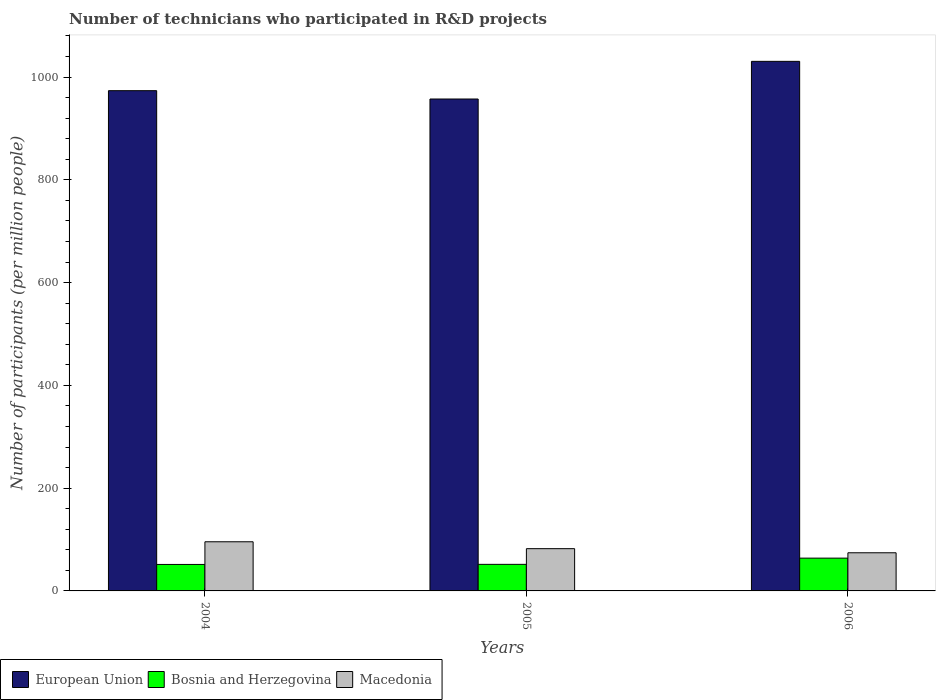How many different coloured bars are there?
Make the answer very short. 3. Are the number of bars on each tick of the X-axis equal?
Offer a very short reply. Yes. How many bars are there on the 1st tick from the right?
Ensure brevity in your answer.  3. What is the label of the 3rd group of bars from the left?
Your response must be concise. 2006. In how many cases, is the number of bars for a given year not equal to the number of legend labels?
Your answer should be compact. 0. What is the number of technicians who participated in R&D projects in European Union in 2004?
Give a very brief answer. 973.54. Across all years, what is the maximum number of technicians who participated in R&D projects in Bosnia and Herzegovina?
Make the answer very short. 63.8. Across all years, what is the minimum number of technicians who participated in R&D projects in Macedonia?
Offer a terse response. 74.24. What is the total number of technicians who participated in R&D projects in European Union in the graph?
Make the answer very short. 2961.45. What is the difference between the number of technicians who participated in R&D projects in European Union in 2004 and that in 2005?
Offer a very short reply. 16.22. What is the difference between the number of technicians who participated in R&D projects in Bosnia and Herzegovina in 2006 and the number of technicians who participated in R&D projects in European Union in 2004?
Offer a very short reply. -909.74. What is the average number of technicians who participated in R&D projects in European Union per year?
Ensure brevity in your answer.  987.15. In the year 2004, what is the difference between the number of technicians who participated in R&D projects in Bosnia and Herzegovina and number of technicians who participated in R&D projects in Macedonia?
Your answer should be very brief. -44.15. What is the ratio of the number of technicians who participated in R&D projects in European Union in 2004 to that in 2005?
Ensure brevity in your answer.  1.02. Is the difference between the number of technicians who participated in R&D projects in Bosnia and Herzegovina in 2004 and 2005 greater than the difference between the number of technicians who participated in R&D projects in Macedonia in 2004 and 2005?
Offer a very short reply. No. What is the difference between the highest and the second highest number of technicians who participated in R&D projects in Macedonia?
Your answer should be compact. 13.42. What is the difference between the highest and the lowest number of technicians who participated in R&D projects in Bosnia and Herzegovina?
Provide a short and direct response. 12.29. Is the sum of the number of technicians who participated in R&D projects in Macedonia in 2005 and 2006 greater than the maximum number of technicians who participated in R&D projects in European Union across all years?
Offer a terse response. No. What does the 3rd bar from the left in 2006 represents?
Give a very brief answer. Macedonia. What does the 2nd bar from the right in 2005 represents?
Provide a succinct answer. Bosnia and Herzegovina. Is it the case that in every year, the sum of the number of technicians who participated in R&D projects in European Union and number of technicians who participated in R&D projects in Bosnia and Herzegovina is greater than the number of technicians who participated in R&D projects in Macedonia?
Ensure brevity in your answer.  Yes. Are all the bars in the graph horizontal?
Ensure brevity in your answer.  No. How many years are there in the graph?
Your answer should be very brief. 3. Does the graph contain grids?
Make the answer very short. No. How are the legend labels stacked?
Give a very brief answer. Horizontal. What is the title of the graph?
Keep it short and to the point. Number of technicians who participated in R&D projects. Does "Bermuda" appear as one of the legend labels in the graph?
Your response must be concise. No. What is the label or title of the Y-axis?
Your response must be concise. Number of participants (per million people). What is the Number of participants (per million people) in European Union in 2004?
Provide a short and direct response. 973.54. What is the Number of participants (per million people) of Bosnia and Herzegovina in 2004?
Your response must be concise. 51.51. What is the Number of participants (per million people) in Macedonia in 2004?
Your answer should be compact. 95.66. What is the Number of participants (per million people) in European Union in 2005?
Offer a terse response. 957.32. What is the Number of participants (per million people) in Bosnia and Herzegovina in 2005?
Provide a short and direct response. 51.7. What is the Number of participants (per million people) of Macedonia in 2005?
Provide a succinct answer. 82.24. What is the Number of participants (per million people) of European Union in 2006?
Your response must be concise. 1030.6. What is the Number of participants (per million people) of Bosnia and Herzegovina in 2006?
Offer a terse response. 63.8. What is the Number of participants (per million people) of Macedonia in 2006?
Give a very brief answer. 74.24. Across all years, what is the maximum Number of participants (per million people) in European Union?
Provide a short and direct response. 1030.6. Across all years, what is the maximum Number of participants (per million people) in Bosnia and Herzegovina?
Offer a very short reply. 63.8. Across all years, what is the maximum Number of participants (per million people) in Macedonia?
Your answer should be compact. 95.66. Across all years, what is the minimum Number of participants (per million people) of European Union?
Ensure brevity in your answer.  957.32. Across all years, what is the minimum Number of participants (per million people) of Bosnia and Herzegovina?
Offer a very short reply. 51.51. Across all years, what is the minimum Number of participants (per million people) in Macedonia?
Offer a terse response. 74.24. What is the total Number of participants (per million people) of European Union in the graph?
Provide a succinct answer. 2961.45. What is the total Number of participants (per million people) of Bosnia and Herzegovina in the graph?
Provide a succinct answer. 167.01. What is the total Number of participants (per million people) in Macedonia in the graph?
Offer a very short reply. 252.14. What is the difference between the Number of participants (per million people) of European Union in 2004 and that in 2005?
Provide a short and direct response. 16.22. What is the difference between the Number of participants (per million people) of Bosnia and Herzegovina in 2004 and that in 2005?
Ensure brevity in your answer.  -0.19. What is the difference between the Number of participants (per million people) in Macedonia in 2004 and that in 2005?
Provide a short and direct response. 13.42. What is the difference between the Number of participants (per million people) of European Union in 2004 and that in 2006?
Your response must be concise. -57.06. What is the difference between the Number of participants (per million people) in Bosnia and Herzegovina in 2004 and that in 2006?
Offer a terse response. -12.29. What is the difference between the Number of participants (per million people) in Macedonia in 2004 and that in 2006?
Offer a very short reply. 21.42. What is the difference between the Number of participants (per million people) of European Union in 2005 and that in 2006?
Your answer should be compact. -73.28. What is the difference between the Number of participants (per million people) of Bosnia and Herzegovina in 2005 and that in 2006?
Make the answer very short. -12.11. What is the difference between the Number of participants (per million people) of Macedonia in 2005 and that in 2006?
Keep it short and to the point. 7.99. What is the difference between the Number of participants (per million people) in European Union in 2004 and the Number of participants (per million people) in Bosnia and Herzegovina in 2005?
Offer a very short reply. 921.84. What is the difference between the Number of participants (per million people) of European Union in 2004 and the Number of participants (per million people) of Macedonia in 2005?
Make the answer very short. 891.3. What is the difference between the Number of participants (per million people) of Bosnia and Herzegovina in 2004 and the Number of participants (per million people) of Macedonia in 2005?
Provide a succinct answer. -30.73. What is the difference between the Number of participants (per million people) of European Union in 2004 and the Number of participants (per million people) of Bosnia and Herzegovina in 2006?
Provide a succinct answer. 909.74. What is the difference between the Number of participants (per million people) in European Union in 2004 and the Number of participants (per million people) in Macedonia in 2006?
Your answer should be very brief. 899.3. What is the difference between the Number of participants (per million people) in Bosnia and Herzegovina in 2004 and the Number of participants (per million people) in Macedonia in 2006?
Provide a short and direct response. -22.73. What is the difference between the Number of participants (per million people) of European Union in 2005 and the Number of participants (per million people) of Bosnia and Herzegovina in 2006?
Your answer should be very brief. 893.52. What is the difference between the Number of participants (per million people) in European Union in 2005 and the Number of participants (per million people) in Macedonia in 2006?
Provide a short and direct response. 883.08. What is the difference between the Number of participants (per million people) of Bosnia and Herzegovina in 2005 and the Number of participants (per million people) of Macedonia in 2006?
Provide a succinct answer. -22.55. What is the average Number of participants (per million people) in European Union per year?
Provide a succinct answer. 987.15. What is the average Number of participants (per million people) in Bosnia and Herzegovina per year?
Provide a succinct answer. 55.67. What is the average Number of participants (per million people) of Macedonia per year?
Provide a short and direct response. 84.05. In the year 2004, what is the difference between the Number of participants (per million people) in European Union and Number of participants (per million people) in Bosnia and Herzegovina?
Offer a very short reply. 922.03. In the year 2004, what is the difference between the Number of participants (per million people) in European Union and Number of participants (per million people) in Macedonia?
Offer a very short reply. 877.88. In the year 2004, what is the difference between the Number of participants (per million people) of Bosnia and Herzegovina and Number of participants (per million people) of Macedonia?
Make the answer very short. -44.15. In the year 2005, what is the difference between the Number of participants (per million people) in European Union and Number of participants (per million people) in Bosnia and Herzegovina?
Provide a short and direct response. 905.62. In the year 2005, what is the difference between the Number of participants (per million people) in European Union and Number of participants (per million people) in Macedonia?
Your answer should be very brief. 875.08. In the year 2005, what is the difference between the Number of participants (per million people) of Bosnia and Herzegovina and Number of participants (per million people) of Macedonia?
Keep it short and to the point. -30.54. In the year 2006, what is the difference between the Number of participants (per million people) of European Union and Number of participants (per million people) of Bosnia and Herzegovina?
Ensure brevity in your answer.  966.79. In the year 2006, what is the difference between the Number of participants (per million people) of European Union and Number of participants (per million people) of Macedonia?
Provide a succinct answer. 956.35. In the year 2006, what is the difference between the Number of participants (per million people) of Bosnia and Herzegovina and Number of participants (per million people) of Macedonia?
Your answer should be compact. -10.44. What is the ratio of the Number of participants (per million people) in European Union in 2004 to that in 2005?
Your answer should be compact. 1.02. What is the ratio of the Number of participants (per million people) in Macedonia in 2004 to that in 2005?
Provide a succinct answer. 1.16. What is the ratio of the Number of participants (per million people) in European Union in 2004 to that in 2006?
Provide a short and direct response. 0.94. What is the ratio of the Number of participants (per million people) of Bosnia and Herzegovina in 2004 to that in 2006?
Offer a very short reply. 0.81. What is the ratio of the Number of participants (per million people) in Macedonia in 2004 to that in 2006?
Ensure brevity in your answer.  1.29. What is the ratio of the Number of participants (per million people) in European Union in 2005 to that in 2006?
Your answer should be very brief. 0.93. What is the ratio of the Number of participants (per million people) of Bosnia and Herzegovina in 2005 to that in 2006?
Your answer should be very brief. 0.81. What is the ratio of the Number of participants (per million people) of Macedonia in 2005 to that in 2006?
Keep it short and to the point. 1.11. What is the difference between the highest and the second highest Number of participants (per million people) in European Union?
Ensure brevity in your answer.  57.06. What is the difference between the highest and the second highest Number of participants (per million people) of Bosnia and Herzegovina?
Offer a terse response. 12.11. What is the difference between the highest and the second highest Number of participants (per million people) of Macedonia?
Keep it short and to the point. 13.42. What is the difference between the highest and the lowest Number of participants (per million people) in European Union?
Make the answer very short. 73.28. What is the difference between the highest and the lowest Number of participants (per million people) in Bosnia and Herzegovina?
Keep it short and to the point. 12.29. What is the difference between the highest and the lowest Number of participants (per million people) of Macedonia?
Provide a short and direct response. 21.42. 